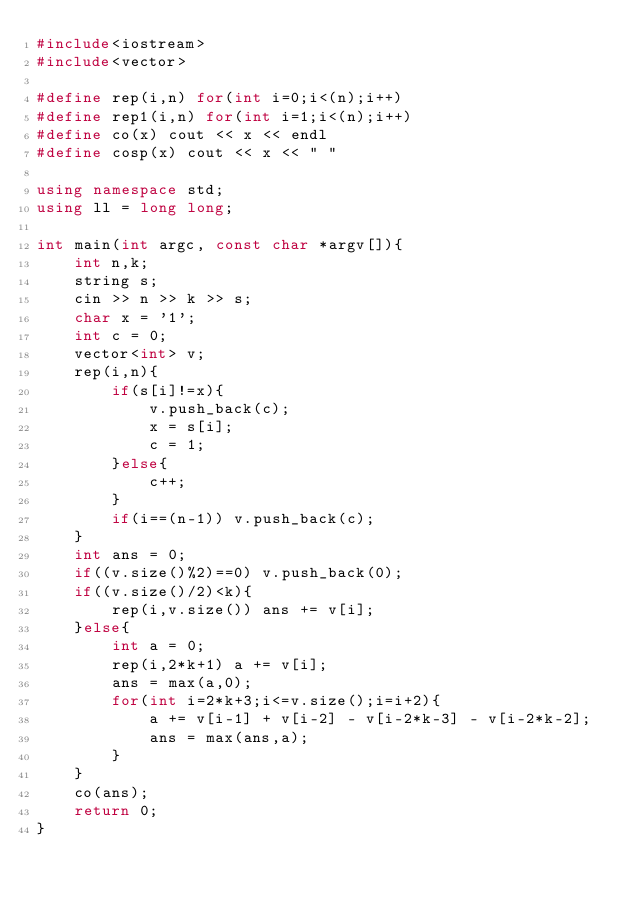Convert code to text. <code><loc_0><loc_0><loc_500><loc_500><_C++_>#include<iostream>
#include<vector>

#define rep(i,n) for(int i=0;i<(n);i++) 
#define rep1(i,n) for(int i=1;i<(n);i++)
#define co(x) cout << x << endl
#define cosp(x) cout << x << " "

using namespace std;
using ll = long long;

int main(int argc, const char *argv[]){
    int n,k;
    string s;
    cin >> n >> k >> s;
    char x = '1';
    int c = 0;
    vector<int> v;
    rep(i,n){
        if(s[i]!=x){
            v.push_back(c);
            x = s[i];
            c = 1;
        }else{
            c++;
        }
        if(i==(n-1)) v.push_back(c);
    }
    int ans = 0;
    if((v.size()%2)==0) v.push_back(0);
    if((v.size()/2)<k){
        rep(i,v.size()) ans += v[i];
    }else{
        int a = 0;
        rep(i,2*k+1) a += v[i];
        ans = max(a,0);
        for(int i=2*k+3;i<=v.size();i=i+2){
            a += v[i-1] + v[i-2] - v[i-2*k-3] - v[i-2*k-2];
            ans = max(ans,a);
        }
    }
    co(ans);
    return 0;
}</code> 